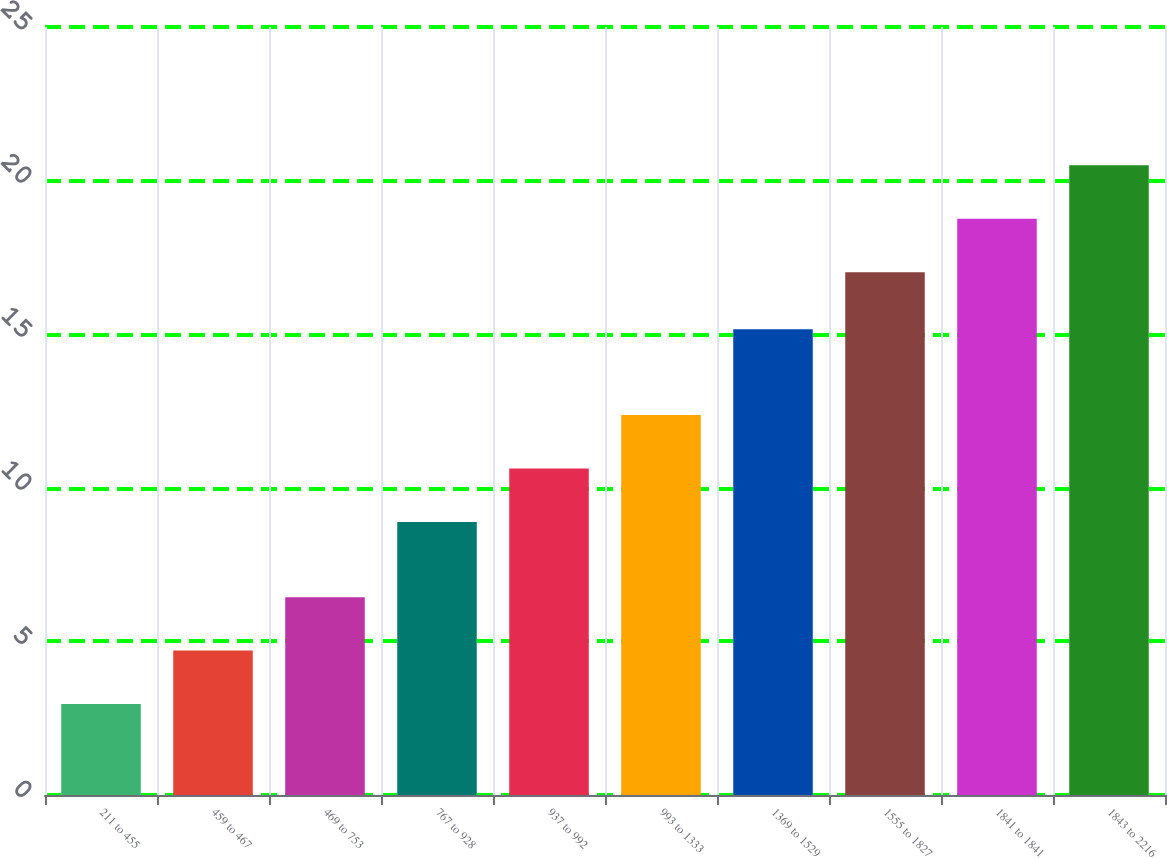Convert chart. <chart><loc_0><loc_0><loc_500><loc_500><bar_chart><fcel>211 to 455<fcel>459 to 467<fcel>469 to 753<fcel>767 to 928<fcel>937 to 992<fcel>993 to 1333<fcel>1369 to 1529<fcel>1555 to 1827<fcel>1841 to 1841<fcel>1843 to 2216<nl><fcel>2.96<fcel>4.7<fcel>6.44<fcel>8.89<fcel>10.63<fcel>12.37<fcel>15.16<fcel>17.02<fcel>18.76<fcel>20.5<nl></chart> 